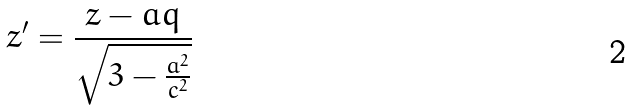Convert formula to latex. <formula><loc_0><loc_0><loc_500><loc_500>z ^ { \prime } = \frac { z - a q } { \sqrt { 3 - \frac { a ^ { 2 } } { c ^ { 2 } } } }</formula> 